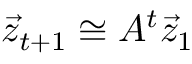Convert formula to latex. <formula><loc_0><loc_0><loc_500><loc_500>\vec { z } _ { t + 1 } \cong A ^ { t } \vec { z } _ { 1 }</formula> 